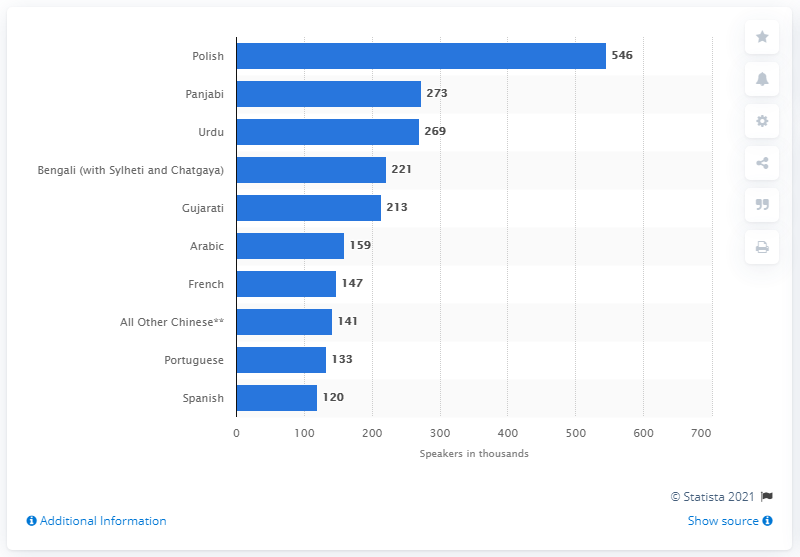Point out several critical features in this image. The most commonly spoken language in England and Wales is Polish. 